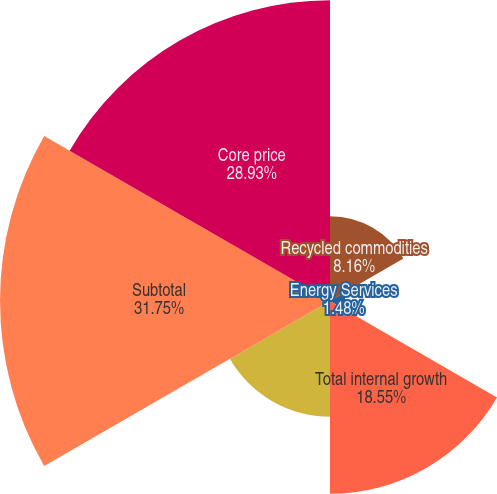<chart> <loc_0><loc_0><loc_500><loc_500><pie_chart><fcel>Recycled commodities<fcel>Energy Services<fcel>Total internal growth<fcel>Acquisitions / divestitures<fcel>Subtotal<fcel>Core price<nl><fcel>8.16%<fcel>1.48%<fcel>18.55%<fcel>11.13%<fcel>31.75%<fcel>28.93%<nl></chart> 